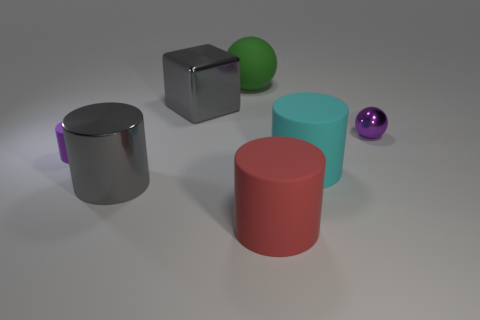Subtract all purple cylinders. How many cylinders are left? 3 Subtract all spheres. How many objects are left? 5 Subtract all gray cylinders. How many yellow cubes are left? 0 Add 3 small matte objects. How many small matte objects are left? 4 Add 6 big blue matte things. How many big blue matte things exist? 6 Add 1 large purple cylinders. How many objects exist? 8 Subtract all cyan cylinders. How many cylinders are left? 3 Subtract 1 purple spheres. How many objects are left? 6 Subtract 4 cylinders. How many cylinders are left? 0 Subtract all blue blocks. Subtract all red balls. How many blocks are left? 1 